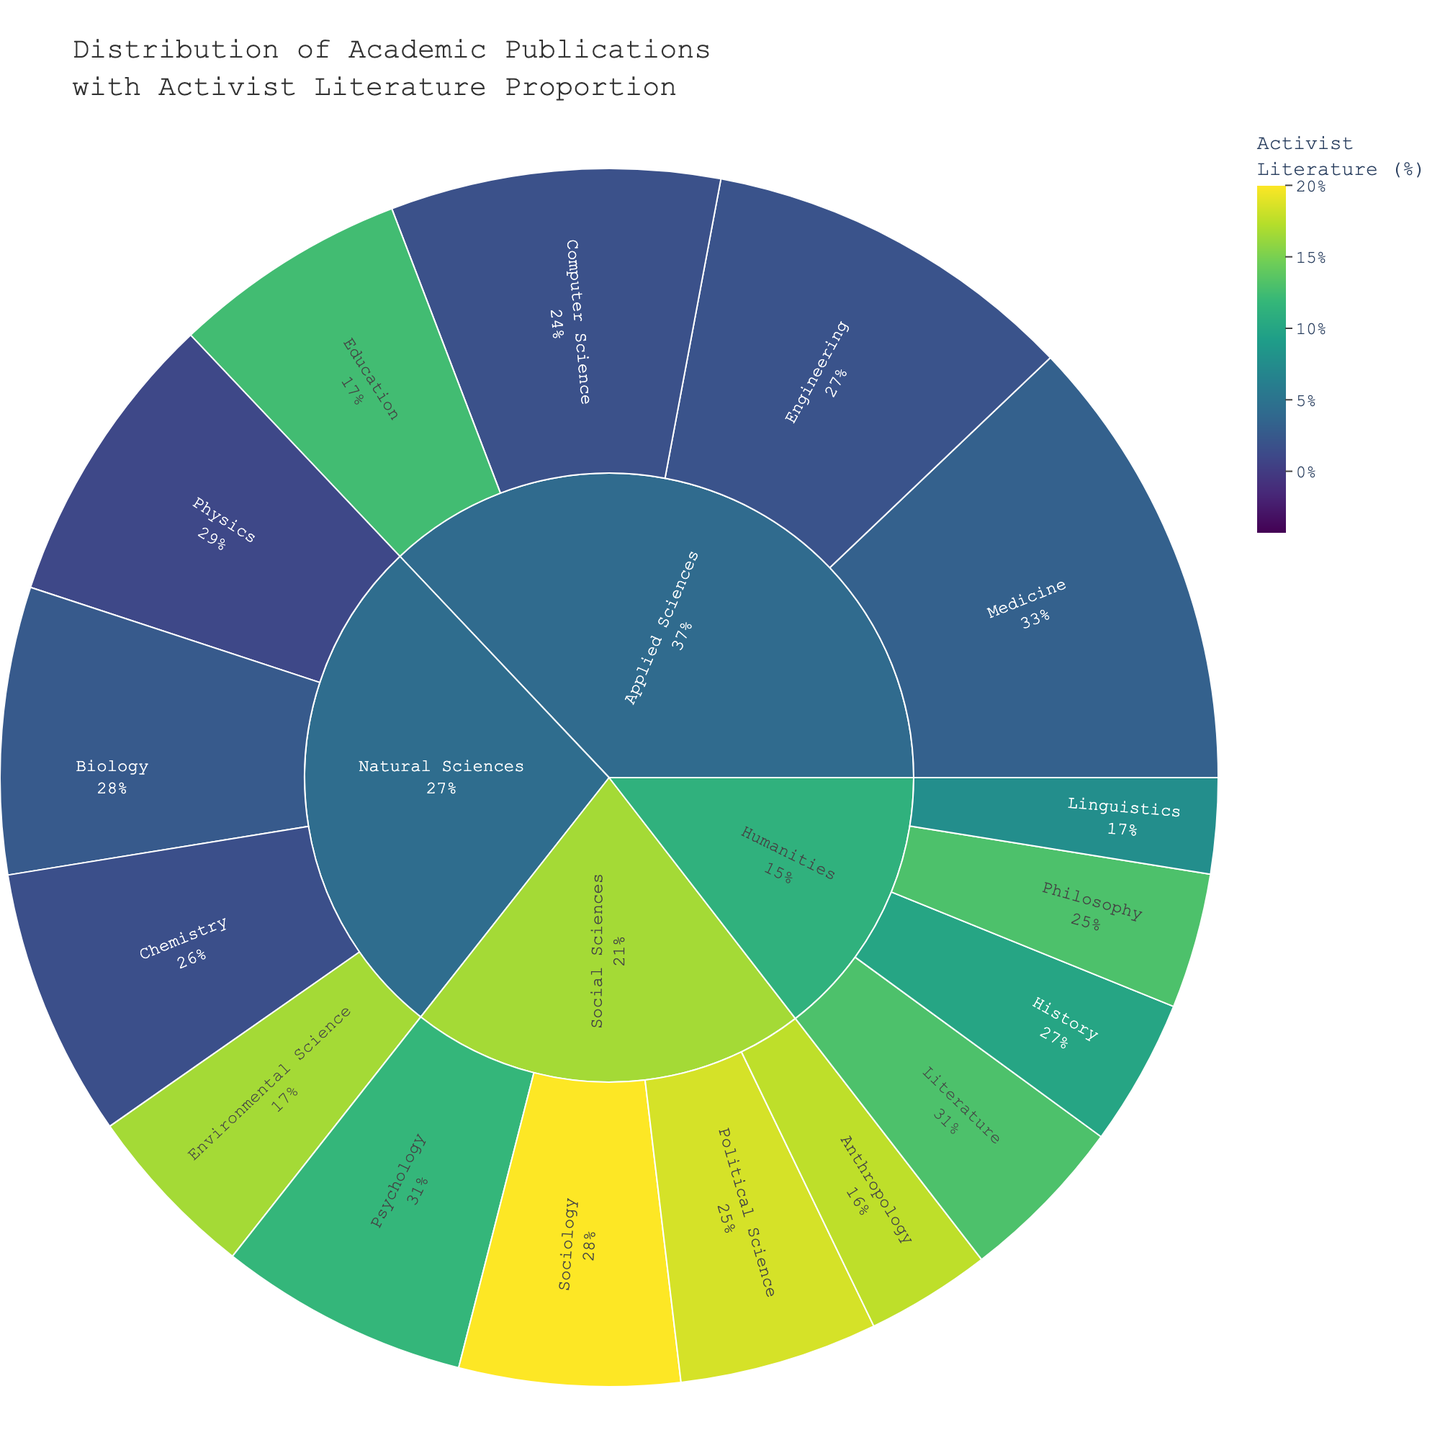What is the title of the figure? The title is usually displayed at the top of the plot and provides a summary of what the figure represents. In this case, the title is "Distribution of Academic Publications with Activist Literature Proportion".
Answer: "Distribution of Academic Publications with Activist Literature Proportion" Which field has the highest number of total academic publications? By visually inspecting the plot, we can notice the relative size of the segments. The "Applied Sciences" field has the largest segment, indicating the highest number of total publications.
Answer: Applied Sciences Which subfield has the highest proportion of activist publications? The color shade in the sunburst plot indicates the proportion of activist publications. "Sociology" in the Social Sciences field has a darker shade compared to other subfields, implying a higher proportion of activist publications.
Answer: Sociology How does the proportion of activist publications in Literature compare to Engineering? By comparing the color shades of both subfields, we can see that the color for "Literature" is darker than that for "Engineering," indicating a higher proportion of activist publications in Literature.
Answer: Literature has a higher proportion What's the total number of activist publications in the Humanities field? We need to sum up the activist publications for all subfields in the Humanities: 150 (Literature) + 120 (Philosophy) + 100 (History) + 50 (Linguistics). The total is 420 activist publications.
Answer: 420 Which subfield in the Natural Sciences field has the largest proportion of activist publications? By observing the color shades within the Natural Sciences field, "Environmental Science" appears to have the darkest shade, indicating the largest proportion of activist publications.
Answer: Environmental Science What is the combined number of publications (both total and activist) in the Political Science and Psychology subfields? We sum the total number of publications and the activist publications for "Political Science" and "Psychology": 
Political Science: 1100 (total) + 250 (activist) 
Psychology: 1500 (total) + 200 (activist) 
Combined total: 1100 + 250 + 1500 + 200 = 3050.
Answer: 3050 Is the proportion of activist publications greater in Sociology or Education? By examining the color intensity of the segments, we compare Sociology and Education. Sociology has a higher proportion (darker color) compared to Education.
Answer: Sociology Which has more activist publications, Natural Sciences or Social Sciences? We need to sum the activist publications for all subfields in these fields:
Natural Sciences: 20 (Physics) + 30 (Chemistry) + 50 (Biology) + 200 (Environmental Science) = 300
Social Sciences: 300 (Sociology) + 200 (Psychology) + 250 (Political Science) + 150 (Anthropology) = 900
The Social Sciences have more activist publications.
Answer: Social Sciences 